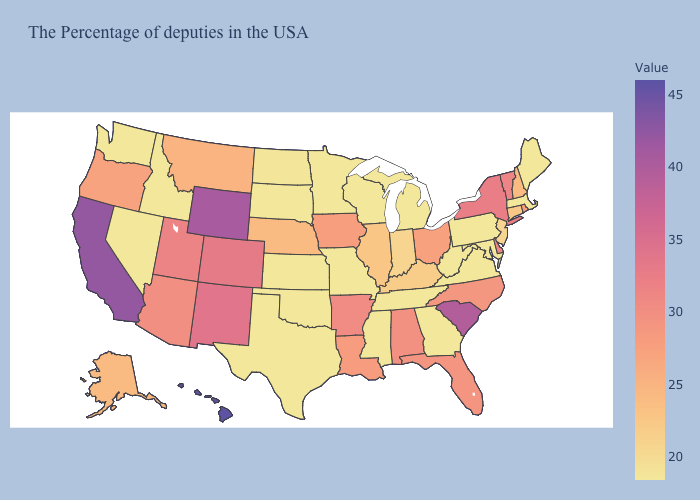Among the states that border Oregon , does Washington have the lowest value?
Concise answer only. Yes. Does the map have missing data?
Give a very brief answer. No. Which states hav the highest value in the Northeast?
Answer briefly. New York. Does North Dakota have the lowest value in the USA?
Give a very brief answer. No. 